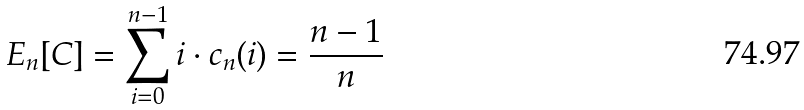Convert formula to latex. <formula><loc_0><loc_0><loc_500><loc_500>E _ { n } [ C ] = \sum _ { i = 0 } ^ { n - 1 } { i \cdot c _ { n } ( i ) } = \frac { n - 1 } { n }</formula> 